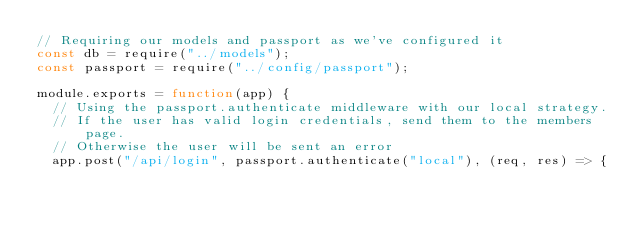<code> <loc_0><loc_0><loc_500><loc_500><_JavaScript_>// Requiring our models and passport as we've configured it
const db = require("../models");
const passport = require("../config/passport");

module.exports = function(app) {
  // Using the passport.authenticate middleware with our local strategy.
  // If the user has valid login credentials, send them to the members page.
  // Otherwise the user will be sent an error
  app.post("/api/login", passport.authenticate("local"), (req, res) => {</code> 